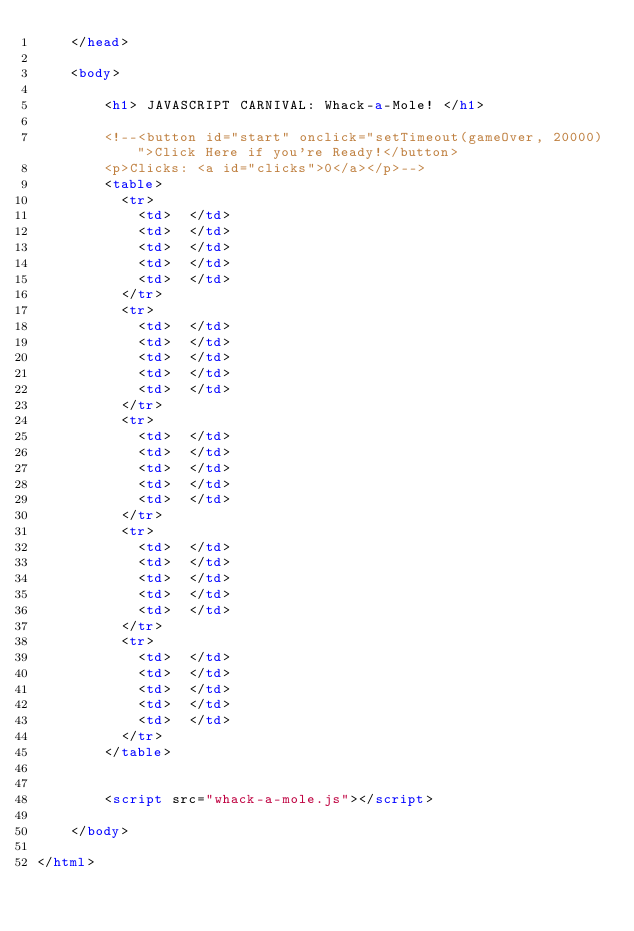Convert code to text. <code><loc_0><loc_0><loc_500><loc_500><_HTML_>	</head>

	<body>

		<h1> JAVASCRIPT CARNIVAL: Whack-a-Mole! </h1>

		<!--<button id="start" onclick="setTimeout(gameOver, 20000)">Click Here if you're Ready!</button>
		<p>Clicks: <a id="clicks">0</a></p>-->
		<table>
		  <tr>
			<td>  </td>
			<td>  </td>
			<td>  </td>
			<td>  </td>
			<td>  </td>
		  </tr>
		  <tr>
			<td>  </td>
			<td>  </td>
			<td>  </td>
			<td>  </td>
			<td>  </td>
		  </tr>
		  <tr>
			<td>  </td>
			<td>  </td>
			<td>  </td>
			<td>  </td>
			<td>  </td>
		  </tr>
		  <tr>
			<td>  </td>
			<td>  </td>
			<td>  </td>
			<td>  </td>
			<td>  </td>
		  </tr>
		  <tr>
			<td>  </td>
			<td>  </td>
			<td>  </td>
			<td>  </td>
			<td>  </td>
		  </tr>
		</table>
		

		<script src="whack-a-mole.js"></script>

	</body>

</html></code> 